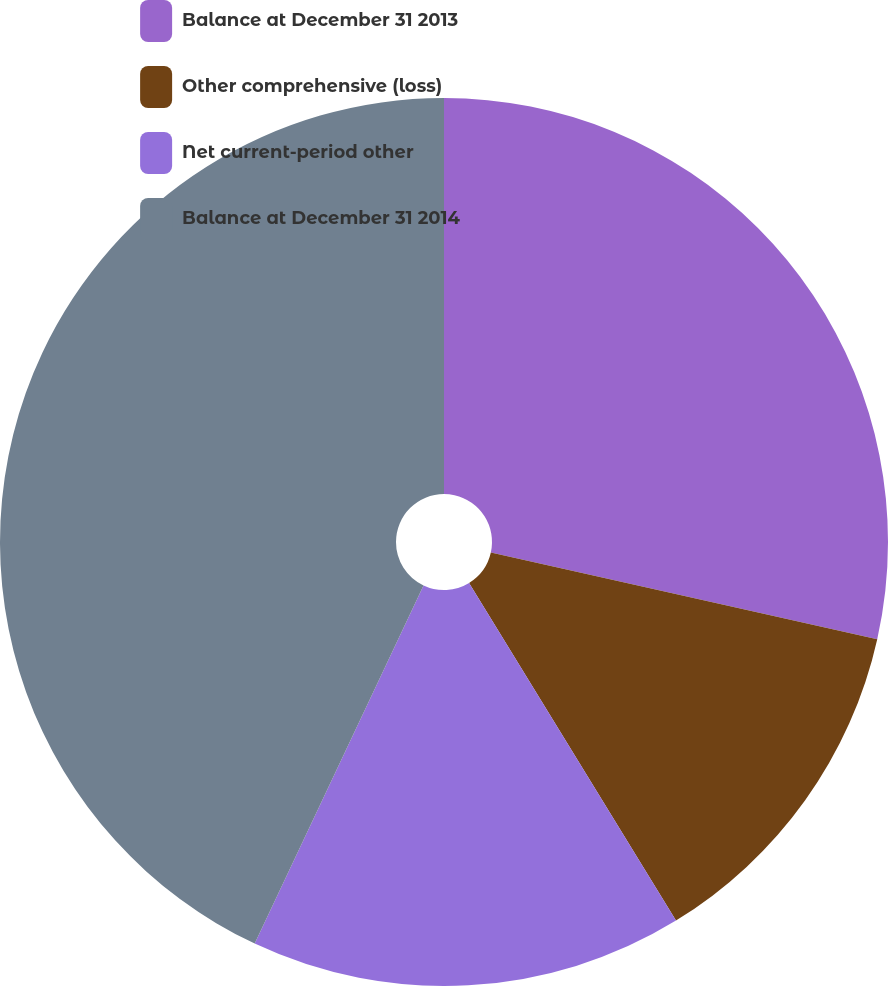Convert chart. <chart><loc_0><loc_0><loc_500><loc_500><pie_chart><fcel>Balance at December 31 2013<fcel>Other comprehensive (loss)<fcel>Net current-period other<fcel>Balance at December 31 2014<nl><fcel>28.51%<fcel>12.74%<fcel>15.76%<fcel>42.99%<nl></chart> 